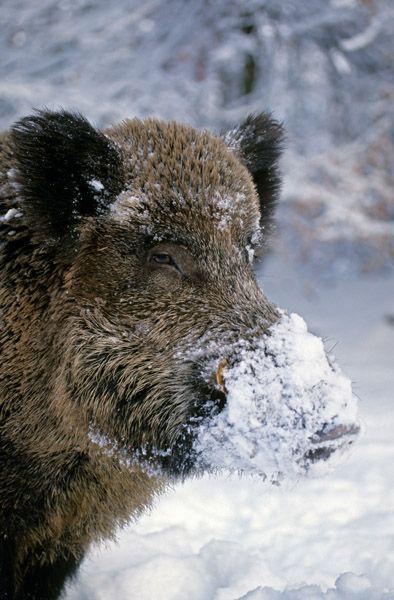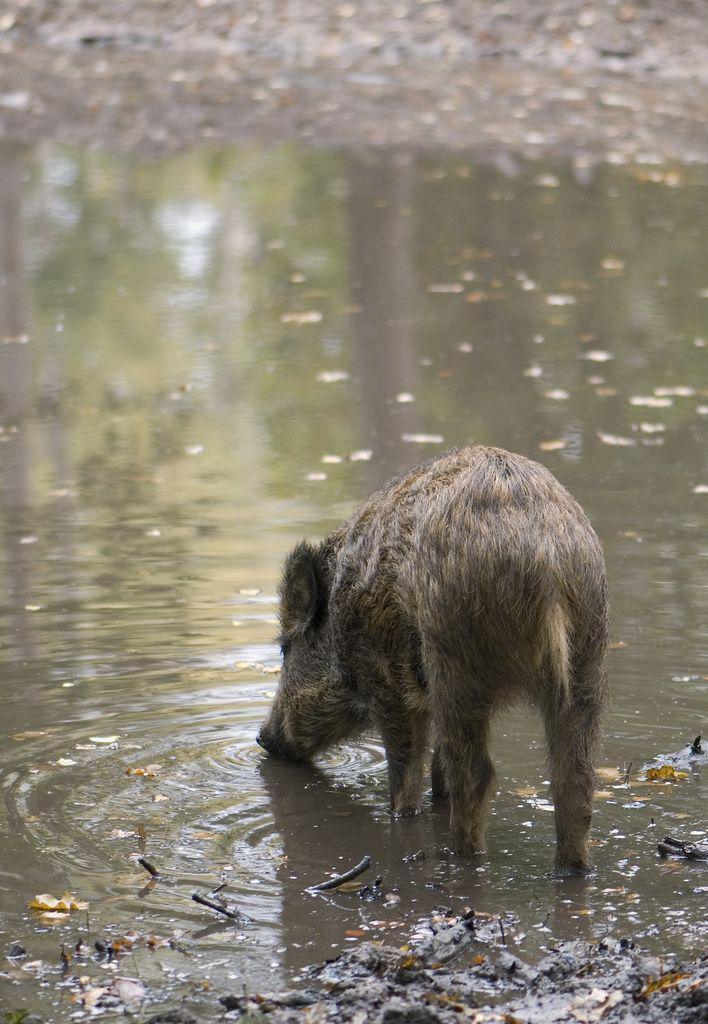The first image is the image on the left, the second image is the image on the right. For the images shown, is this caption "there are two warthogs in the image pair" true? Answer yes or no. Yes. The first image is the image on the left, the second image is the image on the right. For the images shown, is this caption "There are no more than 2 wild pigs." true? Answer yes or no. Yes. 